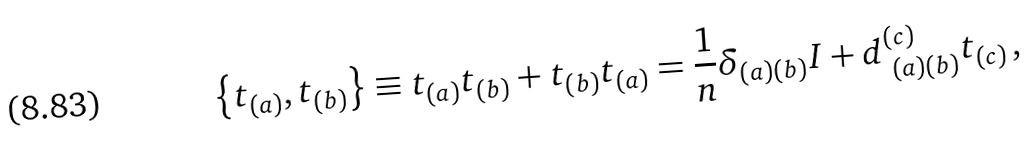Convert formula to latex. <formula><loc_0><loc_0><loc_500><loc_500>\left \{ { t } _ { ( a ) } , { t } _ { ( b ) } \right \} \equiv t _ { ( a ) } { t } _ { ( b ) } + { t } _ { ( b ) } { t } _ { ( a ) } = \frac { 1 } { n } \delta _ { ( a ) ( b ) } { I } + d ^ { ( c ) } _ { \ ( a ) ( b ) } { t } _ { ( c ) } \, ,</formula> 